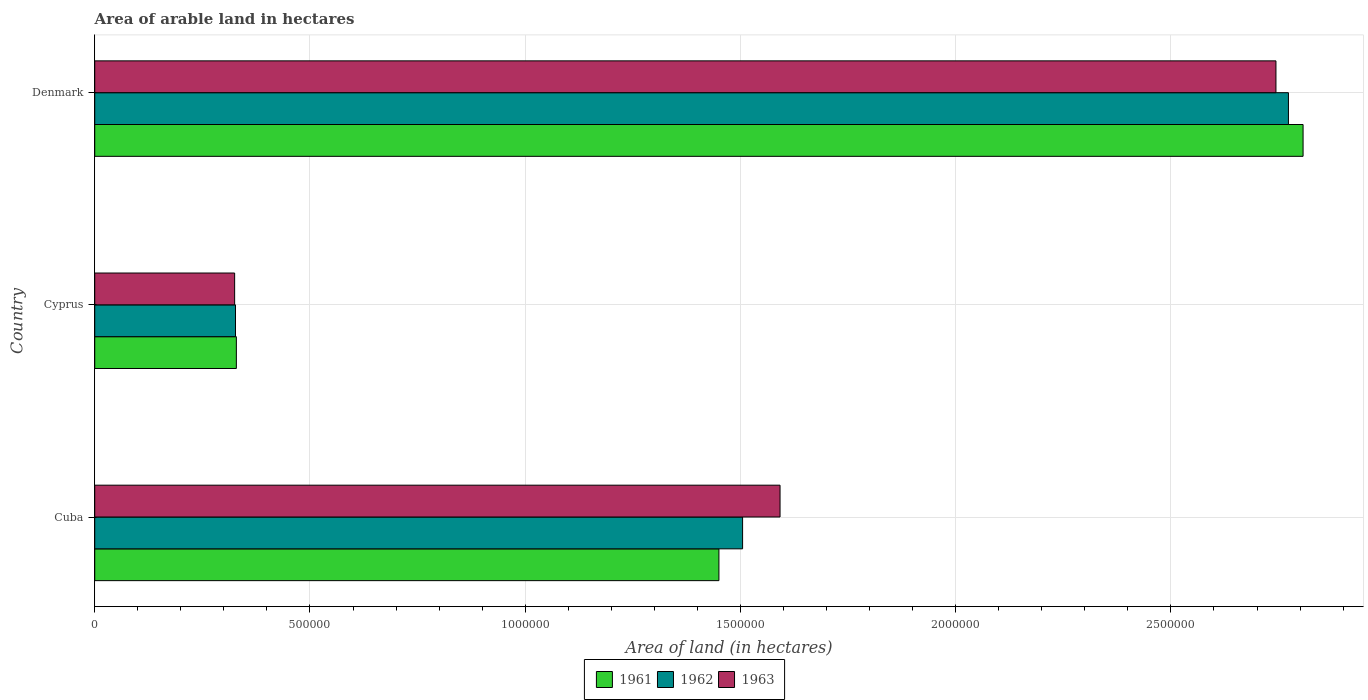How many groups of bars are there?
Your answer should be compact. 3. Are the number of bars per tick equal to the number of legend labels?
Your answer should be very brief. Yes. Are the number of bars on each tick of the Y-axis equal?
Offer a very short reply. Yes. How many bars are there on the 3rd tick from the top?
Make the answer very short. 3. What is the label of the 3rd group of bars from the top?
Make the answer very short. Cuba. In how many cases, is the number of bars for a given country not equal to the number of legend labels?
Make the answer very short. 0. What is the total arable land in 1962 in Cyprus?
Offer a very short reply. 3.27e+05. Across all countries, what is the maximum total arable land in 1961?
Your response must be concise. 2.81e+06. Across all countries, what is the minimum total arable land in 1963?
Ensure brevity in your answer.  3.25e+05. In which country was the total arable land in 1962 maximum?
Make the answer very short. Denmark. In which country was the total arable land in 1961 minimum?
Give a very brief answer. Cyprus. What is the total total arable land in 1961 in the graph?
Ensure brevity in your answer.  4.59e+06. What is the difference between the total arable land in 1961 in Cuba and that in Denmark?
Offer a very short reply. -1.36e+06. What is the difference between the total arable land in 1962 in Denmark and the total arable land in 1963 in Cuba?
Your answer should be compact. 1.18e+06. What is the average total arable land in 1961 per country?
Offer a terse response. 1.53e+06. What is the difference between the total arable land in 1962 and total arable land in 1963 in Denmark?
Make the answer very short. 2.90e+04. In how many countries, is the total arable land in 1961 greater than 2800000 hectares?
Make the answer very short. 1. What is the ratio of the total arable land in 1962 in Cyprus to that in Denmark?
Your answer should be very brief. 0.12. What is the difference between the highest and the second highest total arable land in 1963?
Offer a very short reply. 1.15e+06. What is the difference between the highest and the lowest total arable land in 1963?
Ensure brevity in your answer.  2.42e+06. In how many countries, is the total arable land in 1962 greater than the average total arable land in 1962 taken over all countries?
Your response must be concise. 1. What does the 3rd bar from the top in Cuba represents?
Your answer should be compact. 1961. What does the 3rd bar from the bottom in Cuba represents?
Your answer should be compact. 1963. Is it the case that in every country, the sum of the total arable land in 1961 and total arable land in 1963 is greater than the total arable land in 1962?
Keep it short and to the point. Yes. How many bars are there?
Ensure brevity in your answer.  9. Are all the bars in the graph horizontal?
Your response must be concise. Yes. How many countries are there in the graph?
Provide a short and direct response. 3. What is the difference between two consecutive major ticks on the X-axis?
Offer a terse response. 5.00e+05. Are the values on the major ticks of X-axis written in scientific E-notation?
Keep it short and to the point. No. Does the graph contain grids?
Provide a short and direct response. Yes. How many legend labels are there?
Make the answer very short. 3. How are the legend labels stacked?
Make the answer very short. Horizontal. What is the title of the graph?
Make the answer very short. Area of arable land in hectares. Does "1999" appear as one of the legend labels in the graph?
Keep it short and to the point. No. What is the label or title of the X-axis?
Provide a short and direct response. Area of land (in hectares). What is the Area of land (in hectares) in 1961 in Cuba?
Provide a short and direct response. 1.45e+06. What is the Area of land (in hectares) of 1962 in Cuba?
Offer a very short reply. 1.50e+06. What is the Area of land (in hectares) of 1963 in Cuba?
Provide a succinct answer. 1.59e+06. What is the Area of land (in hectares) in 1961 in Cyprus?
Offer a very short reply. 3.29e+05. What is the Area of land (in hectares) in 1962 in Cyprus?
Your response must be concise. 3.27e+05. What is the Area of land (in hectares) of 1963 in Cyprus?
Ensure brevity in your answer.  3.25e+05. What is the Area of land (in hectares) of 1961 in Denmark?
Give a very brief answer. 2.81e+06. What is the Area of land (in hectares) of 1962 in Denmark?
Provide a succinct answer. 2.77e+06. What is the Area of land (in hectares) of 1963 in Denmark?
Ensure brevity in your answer.  2.74e+06. Across all countries, what is the maximum Area of land (in hectares) of 1961?
Provide a succinct answer. 2.81e+06. Across all countries, what is the maximum Area of land (in hectares) in 1962?
Provide a succinct answer. 2.77e+06. Across all countries, what is the maximum Area of land (in hectares) of 1963?
Keep it short and to the point. 2.74e+06. Across all countries, what is the minimum Area of land (in hectares) of 1961?
Keep it short and to the point. 3.29e+05. Across all countries, what is the minimum Area of land (in hectares) of 1962?
Provide a succinct answer. 3.27e+05. Across all countries, what is the minimum Area of land (in hectares) of 1963?
Your response must be concise. 3.25e+05. What is the total Area of land (in hectares) in 1961 in the graph?
Provide a succinct answer. 4.59e+06. What is the total Area of land (in hectares) of 1962 in the graph?
Your answer should be compact. 4.60e+06. What is the total Area of land (in hectares) of 1963 in the graph?
Your response must be concise. 4.66e+06. What is the difference between the Area of land (in hectares) of 1961 in Cuba and that in Cyprus?
Keep it short and to the point. 1.12e+06. What is the difference between the Area of land (in hectares) in 1962 in Cuba and that in Cyprus?
Your response must be concise. 1.18e+06. What is the difference between the Area of land (in hectares) in 1963 in Cuba and that in Cyprus?
Your answer should be very brief. 1.27e+06. What is the difference between the Area of land (in hectares) of 1961 in Cuba and that in Denmark?
Your answer should be very brief. -1.36e+06. What is the difference between the Area of land (in hectares) of 1962 in Cuba and that in Denmark?
Offer a terse response. -1.27e+06. What is the difference between the Area of land (in hectares) in 1963 in Cuba and that in Denmark?
Offer a terse response. -1.15e+06. What is the difference between the Area of land (in hectares) in 1961 in Cyprus and that in Denmark?
Make the answer very short. -2.48e+06. What is the difference between the Area of land (in hectares) in 1962 in Cyprus and that in Denmark?
Provide a short and direct response. -2.45e+06. What is the difference between the Area of land (in hectares) of 1963 in Cyprus and that in Denmark?
Offer a terse response. -2.42e+06. What is the difference between the Area of land (in hectares) of 1961 in Cuba and the Area of land (in hectares) of 1962 in Cyprus?
Keep it short and to the point. 1.12e+06. What is the difference between the Area of land (in hectares) of 1961 in Cuba and the Area of land (in hectares) of 1963 in Cyprus?
Your response must be concise. 1.12e+06. What is the difference between the Area of land (in hectares) of 1962 in Cuba and the Area of land (in hectares) of 1963 in Cyprus?
Make the answer very short. 1.18e+06. What is the difference between the Area of land (in hectares) in 1961 in Cuba and the Area of land (in hectares) in 1962 in Denmark?
Your answer should be compact. -1.32e+06. What is the difference between the Area of land (in hectares) in 1961 in Cuba and the Area of land (in hectares) in 1963 in Denmark?
Keep it short and to the point. -1.29e+06. What is the difference between the Area of land (in hectares) of 1962 in Cuba and the Area of land (in hectares) of 1963 in Denmark?
Offer a terse response. -1.24e+06. What is the difference between the Area of land (in hectares) in 1961 in Cyprus and the Area of land (in hectares) in 1962 in Denmark?
Your answer should be very brief. -2.44e+06. What is the difference between the Area of land (in hectares) in 1961 in Cyprus and the Area of land (in hectares) in 1963 in Denmark?
Offer a very short reply. -2.42e+06. What is the difference between the Area of land (in hectares) in 1962 in Cyprus and the Area of land (in hectares) in 1963 in Denmark?
Make the answer very short. -2.42e+06. What is the average Area of land (in hectares) of 1961 per country?
Give a very brief answer. 1.53e+06. What is the average Area of land (in hectares) of 1962 per country?
Offer a terse response. 1.54e+06. What is the average Area of land (in hectares) of 1963 per country?
Ensure brevity in your answer.  1.55e+06. What is the difference between the Area of land (in hectares) of 1961 and Area of land (in hectares) of 1962 in Cuba?
Offer a very short reply. -5.50e+04. What is the difference between the Area of land (in hectares) of 1961 and Area of land (in hectares) of 1963 in Cuba?
Your response must be concise. -1.42e+05. What is the difference between the Area of land (in hectares) of 1962 and Area of land (in hectares) of 1963 in Cuba?
Your answer should be compact. -8.70e+04. What is the difference between the Area of land (in hectares) of 1961 and Area of land (in hectares) of 1963 in Cyprus?
Provide a short and direct response. 4000. What is the difference between the Area of land (in hectares) of 1962 and Area of land (in hectares) of 1963 in Cyprus?
Offer a terse response. 2000. What is the difference between the Area of land (in hectares) in 1961 and Area of land (in hectares) in 1962 in Denmark?
Your response must be concise. 3.40e+04. What is the difference between the Area of land (in hectares) of 1961 and Area of land (in hectares) of 1963 in Denmark?
Your response must be concise. 6.30e+04. What is the difference between the Area of land (in hectares) in 1962 and Area of land (in hectares) in 1963 in Denmark?
Your answer should be compact. 2.90e+04. What is the ratio of the Area of land (in hectares) in 1961 in Cuba to that in Cyprus?
Keep it short and to the point. 4.41. What is the ratio of the Area of land (in hectares) of 1962 in Cuba to that in Cyprus?
Offer a very short reply. 4.6. What is the ratio of the Area of land (in hectares) of 1963 in Cuba to that in Cyprus?
Ensure brevity in your answer.  4.9. What is the ratio of the Area of land (in hectares) in 1961 in Cuba to that in Denmark?
Make the answer very short. 0.52. What is the ratio of the Area of land (in hectares) in 1962 in Cuba to that in Denmark?
Offer a very short reply. 0.54. What is the ratio of the Area of land (in hectares) of 1963 in Cuba to that in Denmark?
Offer a very short reply. 0.58. What is the ratio of the Area of land (in hectares) of 1961 in Cyprus to that in Denmark?
Keep it short and to the point. 0.12. What is the ratio of the Area of land (in hectares) in 1962 in Cyprus to that in Denmark?
Your answer should be very brief. 0.12. What is the ratio of the Area of land (in hectares) of 1963 in Cyprus to that in Denmark?
Your response must be concise. 0.12. What is the difference between the highest and the second highest Area of land (in hectares) of 1961?
Your answer should be very brief. 1.36e+06. What is the difference between the highest and the second highest Area of land (in hectares) of 1962?
Ensure brevity in your answer.  1.27e+06. What is the difference between the highest and the second highest Area of land (in hectares) in 1963?
Keep it short and to the point. 1.15e+06. What is the difference between the highest and the lowest Area of land (in hectares) of 1961?
Give a very brief answer. 2.48e+06. What is the difference between the highest and the lowest Area of land (in hectares) of 1962?
Your answer should be compact. 2.45e+06. What is the difference between the highest and the lowest Area of land (in hectares) in 1963?
Offer a terse response. 2.42e+06. 